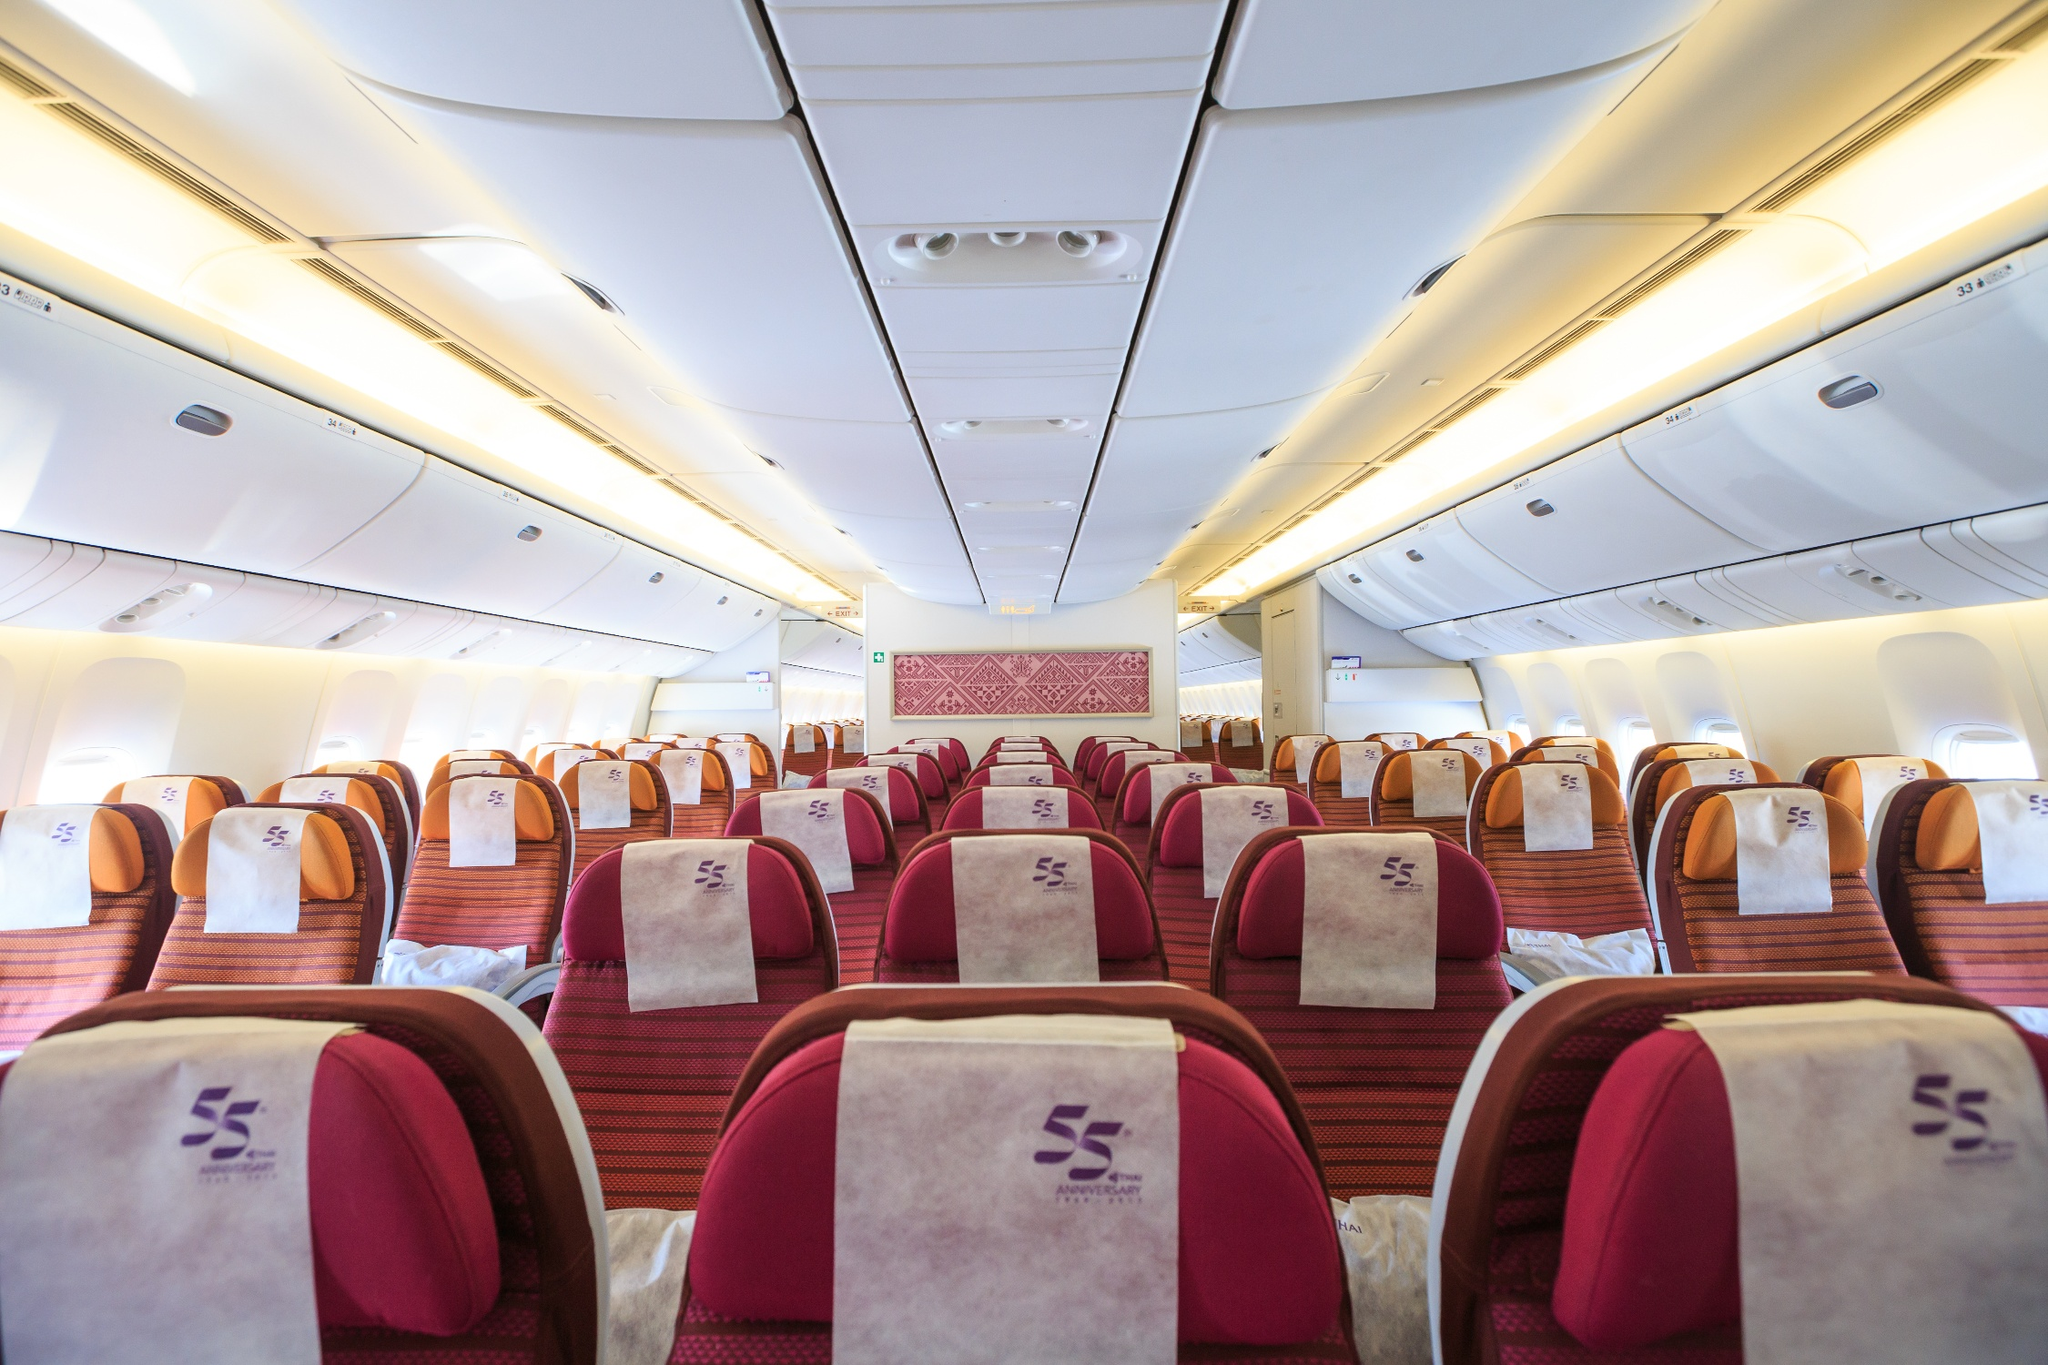Can you describe the comfort features visible in this airplane cabin? The cabin is designed with passenger comfort in mind. The seats are covered in plush, deep red fabric and are equipped with adjustable headrests, which are essential for neck support during long flights. The light beige overhead bins provide ample space for carry-on luggage, minimizing clutter and ensuring a more relaxed travel environment. The air vents are strategically placed to optimize airflow, enhancing the overall passenger comfort. 